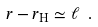<formula> <loc_0><loc_0><loc_500><loc_500>r - r _ { \text {H} } \simeq \ell \ .</formula> 